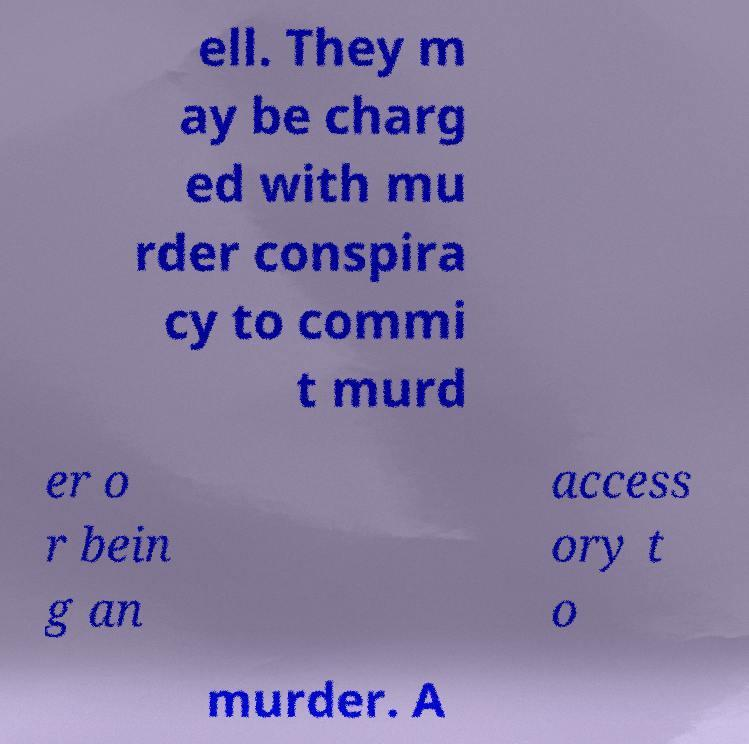I need the written content from this picture converted into text. Can you do that? ell. They m ay be charg ed with mu rder conspira cy to commi t murd er o r bein g an access ory t o murder. A 